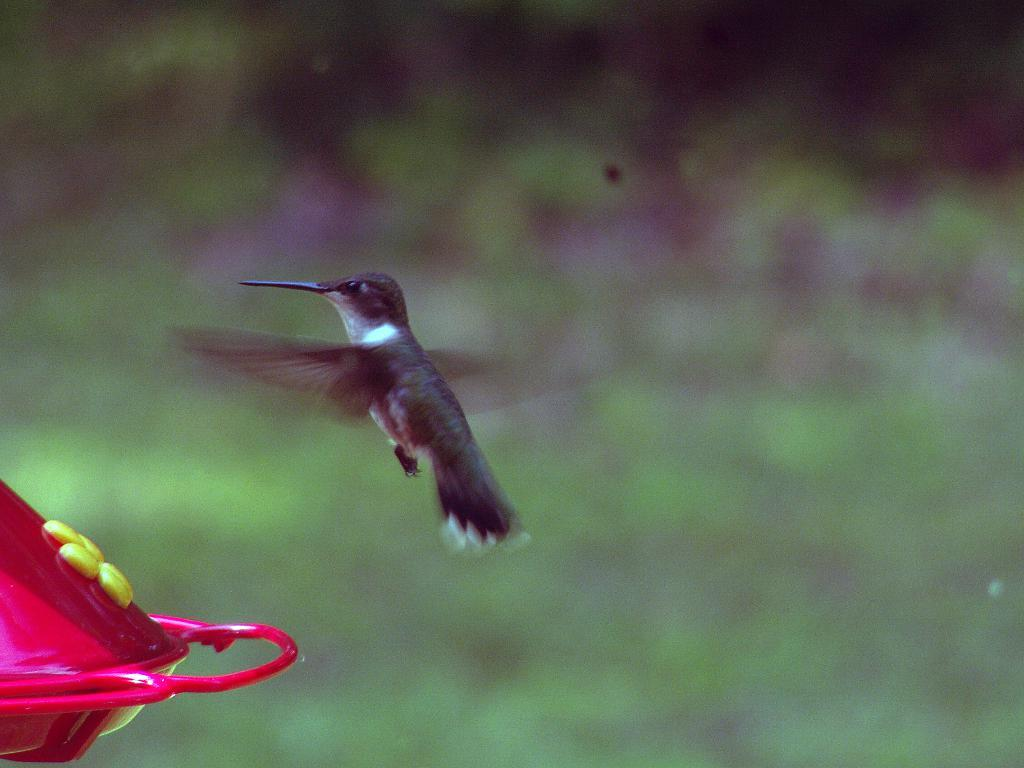What is the main subject of the image? The main subject of the image is a bird flying in the air. Where is the bird located in the image? The bird is in the center of the image. What else can be seen in the image besides the bird? There is an object at the bottom left of the image. How many boys are playing with salt in the image? There are no boys or salt present in the image. 